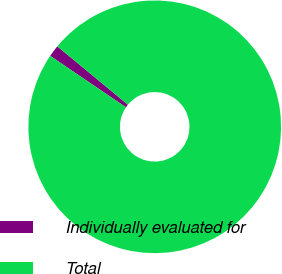Convert chart. <chart><loc_0><loc_0><loc_500><loc_500><pie_chart><fcel>Individually evaluated for<fcel>Total<nl><fcel>1.5%<fcel>98.5%<nl></chart> 